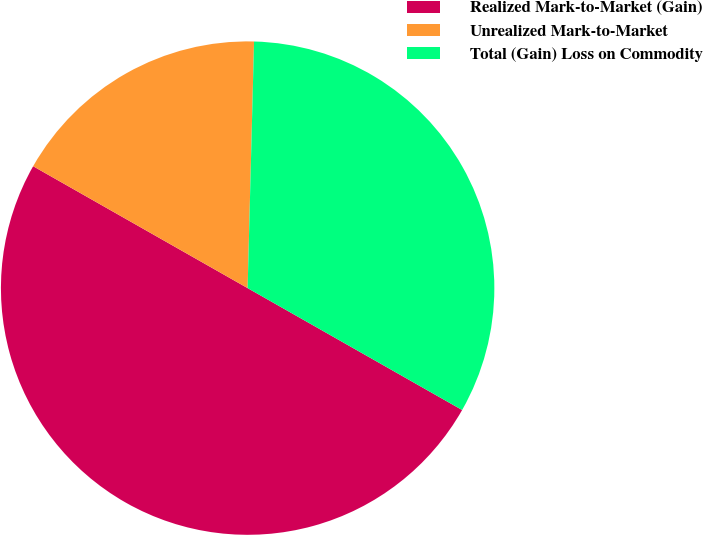Convert chart to OTSL. <chart><loc_0><loc_0><loc_500><loc_500><pie_chart><fcel>Realized Mark-to-Market (Gain)<fcel>Unrealized Mark-to-Market<fcel>Total (Gain) Loss on Commodity<nl><fcel>50.0%<fcel>17.19%<fcel>32.81%<nl></chart> 